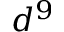<formula> <loc_0><loc_0><loc_500><loc_500>d ^ { 9 }</formula> 